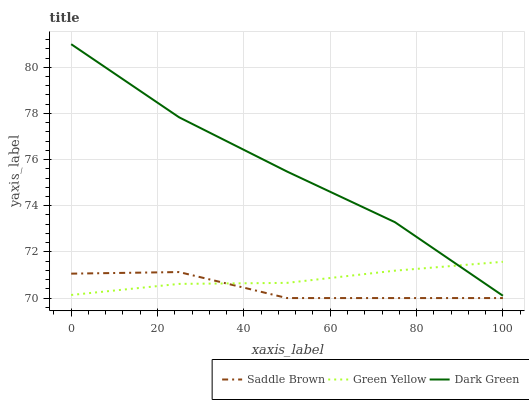Does Saddle Brown have the minimum area under the curve?
Answer yes or no. Yes. Does Dark Green have the maximum area under the curve?
Answer yes or no. Yes. Does Dark Green have the minimum area under the curve?
Answer yes or no. No. Does Saddle Brown have the maximum area under the curve?
Answer yes or no. No. Is Green Yellow the smoothest?
Answer yes or no. Yes. Is Saddle Brown the roughest?
Answer yes or no. Yes. Is Dark Green the smoothest?
Answer yes or no. No. Is Dark Green the roughest?
Answer yes or no. No. Does Dark Green have the lowest value?
Answer yes or no. No. Does Dark Green have the highest value?
Answer yes or no. Yes. Does Saddle Brown have the highest value?
Answer yes or no. No. Is Saddle Brown less than Dark Green?
Answer yes or no. Yes. Is Dark Green greater than Saddle Brown?
Answer yes or no. Yes. Does Saddle Brown intersect Green Yellow?
Answer yes or no. Yes. Is Saddle Brown less than Green Yellow?
Answer yes or no. No. Is Saddle Brown greater than Green Yellow?
Answer yes or no. No. Does Saddle Brown intersect Dark Green?
Answer yes or no. No. 